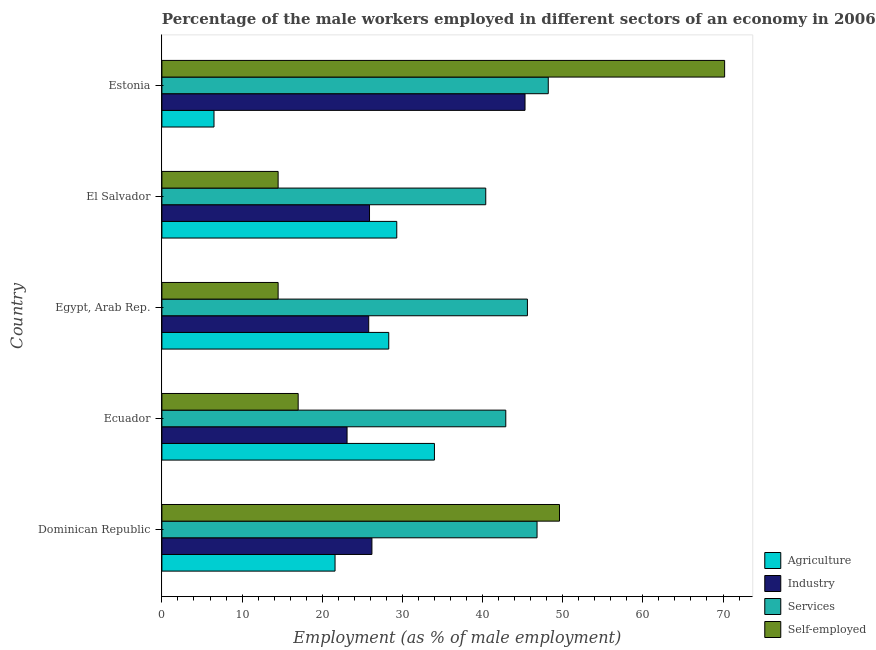What is the label of the 2nd group of bars from the top?
Offer a terse response. El Salvador. What is the percentage of male workers in services in Ecuador?
Your answer should be very brief. 42.9. Across all countries, what is the maximum percentage of self employed male workers?
Keep it short and to the point. 70.2. Across all countries, what is the minimum percentage of male workers in industry?
Give a very brief answer. 23.1. In which country was the percentage of male workers in services maximum?
Provide a succinct answer. Estonia. In which country was the percentage of male workers in services minimum?
Provide a succinct answer. El Salvador. What is the total percentage of male workers in agriculture in the graph?
Your response must be concise. 119.7. What is the difference between the percentage of self employed male workers in Ecuador and that in El Salvador?
Ensure brevity in your answer.  2.5. What is the difference between the percentage of self employed male workers in Estonia and the percentage of male workers in industry in Ecuador?
Offer a terse response. 47.1. What is the average percentage of male workers in industry per country?
Your answer should be compact. 29.26. What is the difference between the percentage of male workers in services and percentage of male workers in industry in Ecuador?
Ensure brevity in your answer.  19.8. What is the ratio of the percentage of male workers in services in Ecuador to that in Estonia?
Offer a very short reply. 0.89. Is the percentage of self employed male workers in Ecuador less than that in Egypt, Arab Rep.?
Keep it short and to the point. No. What is the difference between the highest and the second highest percentage of male workers in industry?
Give a very brief answer. 19.1. In how many countries, is the percentage of male workers in agriculture greater than the average percentage of male workers in agriculture taken over all countries?
Give a very brief answer. 3. Is it the case that in every country, the sum of the percentage of self employed male workers and percentage of male workers in agriculture is greater than the sum of percentage of male workers in services and percentage of male workers in industry?
Provide a succinct answer. No. What does the 1st bar from the top in El Salvador represents?
Provide a succinct answer. Self-employed. What does the 4th bar from the bottom in Ecuador represents?
Your answer should be compact. Self-employed. How many countries are there in the graph?
Offer a very short reply. 5. What is the difference between two consecutive major ticks on the X-axis?
Your answer should be compact. 10. Where does the legend appear in the graph?
Offer a terse response. Bottom right. What is the title of the graph?
Provide a succinct answer. Percentage of the male workers employed in different sectors of an economy in 2006. Does "Agriculture" appear as one of the legend labels in the graph?
Make the answer very short. Yes. What is the label or title of the X-axis?
Your response must be concise. Employment (as % of male employment). What is the Employment (as % of male employment) in Agriculture in Dominican Republic?
Make the answer very short. 21.6. What is the Employment (as % of male employment) in Industry in Dominican Republic?
Your answer should be compact. 26.2. What is the Employment (as % of male employment) of Services in Dominican Republic?
Give a very brief answer. 46.8. What is the Employment (as % of male employment) in Self-employed in Dominican Republic?
Offer a very short reply. 49.6. What is the Employment (as % of male employment) of Industry in Ecuador?
Your answer should be very brief. 23.1. What is the Employment (as % of male employment) of Services in Ecuador?
Provide a short and direct response. 42.9. What is the Employment (as % of male employment) in Self-employed in Ecuador?
Give a very brief answer. 17. What is the Employment (as % of male employment) of Agriculture in Egypt, Arab Rep.?
Make the answer very short. 28.3. What is the Employment (as % of male employment) of Industry in Egypt, Arab Rep.?
Your response must be concise. 25.8. What is the Employment (as % of male employment) of Services in Egypt, Arab Rep.?
Your answer should be compact. 45.6. What is the Employment (as % of male employment) in Agriculture in El Salvador?
Your answer should be compact. 29.3. What is the Employment (as % of male employment) in Industry in El Salvador?
Offer a terse response. 25.9. What is the Employment (as % of male employment) in Services in El Salvador?
Your response must be concise. 40.4. What is the Employment (as % of male employment) in Self-employed in El Salvador?
Your answer should be compact. 14.5. What is the Employment (as % of male employment) of Agriculture in Estonia?
Your answer should be very brief. 6.5. What is the Employment (as % of male employment) of Industry in Estonia?
Offer a terse response. 45.3. What is the Employment (as % of male employment) in Services in Estonia?
Your answer should be compact. 48.2. What is the Employment (as % of male employment) in Self-employed in Estonia?
Provide a succinct answer. 70.2. Across all countries, what is the maximum Employment (as % of male employment) of Industry?
Make the answer very short. 45.3. Across all countries, what is the maximum Employment (as % of male employment) of Services?
Offer a very short reply. 48.2. Across all countries, what is the maximum Employment (as % of male employment) of Self-employed?
Offer a very short reply. 70.2. Across all countries, what is the minimum Employment (as % of male employment) in Agriculture?
Your answer should be compact. 6.5. Across all countries, what is the minimum Employment (as % of male employment) in Industry?
Offer a terse response. 23.1. Across all countries, what is the minimum Employment (as % of male employment) of Services?
Keep it short and to the point. 40.4. Across all countries, what is the minimum Employment (as % of male employment) of Self-employed?
Give a very brief answer. 14.5. What is the total Employment (as % of male employment) of Agriculture in the graph?
Ensure brevity in your answer.  119.7. What is the total Employment (as % of male employment) in Industry in the graph?
Provide a succinct answer. 146.3. What is the total Employment (as % of male employment) in Services in the graph?
Offer a very short reply. 223.9. What is the total Employment (as % of male employment) of Self-employed in the graph?
Offer a terse response. 165.8. What is the difference between the Employment (as % of male employment) of Agriculture in Dominican Republic and that in Ecuador?
Offer a very short reply. -12.4. What is the difference between the Employment (as % of male employment) of Industry in Dominican Republic and that in Ecuador?
Your response must be concise. 3.1. What is the difference between the Employment (as % of male employment) of Services in Dominican Republic and that in Ecuador?
Make the answer very short. 3.9. What is the difference between the Employment (as % of male employment) in Self-employed in Dominican Republic and that in Ecuador?
Your answer should be compact. 32.6. What is the difference between the Employment (as % of male employment) of Agriculture in Dominican Republic and that in Egypt, Arab Rep.?
Make the answer very short. -6.7. What is the difference between the Employment (as % of male employment) of Services in Dominican Republic and that in Egypt, Arab Rep.?
Offer a very short reply. 1.2. What is the difference between the Employment (as % of male employment) of Self-employed in Dominican Republic and that in Egypt, Arab Rep.?
Keep it short and to the point. 35.1. What is the difference between the Employment (as % of male employment) of Agriculture in Dominican Republic and that in El Salvador?
Your response must be concise. -7.7. What is the difference between the Employment (as % of male employment) in Industry in Dominican Republic and that in El Salvador?
Provide a short and direct response. 0.3. What is the difference between the Employment (as % of male employment) of Self-employed in Dominican Republic and that in El Salvador?
Your answer should be very brief. 35.1. What is the difference between the Employment (as % of male employment) of Industry in Dominican Republic and that in Estonia?
Give a very brief answer. -19.1. What is the difference between the Employment (as % of male employment) in Services in Dominican Republic and that in Estonia?
Your answer should be compact. -1.4. What is the difference between the Employment (as % of male employment) of Self-employed in Dominican Republic and that in Estonia?
Provide a short and direct response. -20.6. What is the difference between the Employment (as % of male employment) of Agriculture in Ecuador and that in Egypt, Arab Rep.?
Offer a terse response. 5.7. What is the difference between the Employment (as % of male employment) in Industry in Ecuador and that in Egypt, Arab Rep.?
Offer a terse response. -2.7. What is the difference between the Employment (as % of male employment) in Agriculture in Ecuador and that in El Salvador?
Keep it short and to the point. 4.7. What is the difference between the Employment (as % of male employment) of Industry in Ecuador and that in El Salvador?
Ensure brevity in your answer.  -2.8. What is the difference between the Employment (as % of male employment) in Agriculture in Ecuador and that in Estonia?
Give a very brief answer. 27.5. What is the difference between the Employment (as % of male employment) in Industry in Ecuador and that in Estonia?
Offer a terse response. -22.2. What is the difference between the Employment (as % of male employment) of Services in Ecuador and that in Estonia?
Ensure brevity in your answer.  -5.3. What is the difference between the Employment (as % of male employment) of Self-employed in Ecuador and that in Estonia?
Your answer should be very brief. -53.2. What is the difference between the Employment (as % of male employment) of Services in Egypt, Arab Rep. and that in El Salvador?
Offer a very short reply. 5.2. What is the difference between the Employment (as % of male employment) of Agriculture in Egypt, Arab Rep. and that in Estonia?
Provide a short and direct response. 21.8. What is the difference between the Employment (as % of male employment) in Industry in Egypt, Arab Rep. and that in Estonia?
Give a very brief answer. -19.5. What is the difference between the Employment (as % of male employment) in Self-employed in Egypt, Arab Rep. and that in Estonia?
Provide a short and direct response. -55.7. What is the difference between the Employment (as % of male employment) of Agriculture in El Salvador and that in Estonia?
Your response must be concise. 22.8. What is the difference between the Employment (as % of male employment) of Industry in El Salvador and that in Estonia?
Ensure brevity in your answer.  -19.4. What is the difference between the Employment (as % of male employment) of Self-employed in El Salvador and that in Estonia?
Give a very brief answer. -55.7. What is the difference between the Employment (as % of male employment) in Agriculture in Dominican Republic and the Employment (as % of male employment) in Industry in Ecuador?
Provide a succinct answer. -1.5. What is the difference between the Employment (as % of male employment) in Agriculture in Dominican Republic and the Employment (as % of male employment) in Services in Ecuador?
Give a very brief answer. -21.3. What is the difference between the Employment (as % of male employment) in Agriculture in Dominican Republic and the Employment (as % of male employment) in Self-employed in Ecuador?
Give a very brief answer. 4.6. What is the difference between the Employment (as % of male employment) of Industry in Dominican Republic and the Employment (as % of male employment) of Services in Ecuador?
Offer a very short reply. -16.7. What is the difference between the Employment (as % of male employment) in Services in Dominican Republic and the Employment (as % of male employment) in Self-employed in Ecuador?
Your answer should be very brief. 29.8. What is the difference between the Employment (as % of male employment) of Agriculture in Dominican Republic and the Employment (as % of male employment) of Services in Egypt, Arab Rep.?
Offer a very short reply. -24. What is the difference between the Employment (as % of male employment) in Industry in Dominican Republic and the Employment (as % of male employment) in Services in Egypt, Arab Rep.?
Keep it short and to the point. -19.4. What is the difference between the Employment (as % of male employment) in Industry in Dominican Republic and the Employment (as % of male employment) in Self-employed in Egypt, Arab Rep.?
Provide a short and direct response. 11.7. What is the difference between the Employment (as % of male employment) of Services in Dominican Republic and the Employment (as % of male employment) of Self-employed in Egypt, Arab Rep.?
Make the answer very short. 32.3. What is the difference between the Employment (as % of male employment) in Agriculture in Dominican Republic and the Employment (as % of male employment) in Industry in El Salvador?
Provide a succinct answer. -4.3. What is the difference between the Employment (as % of male employment) of Agriculture in Dominican Republic and the Employment (as % of male employment) of Services in El Salvador?
Keep it short and to the point. -18.8. What is the difference between the Employment (as % of male employment) in Services in Dominican Republic and the Employment (as % of male employment) in Self-employed in El Salvador?
Your response must be concise. 32.3. What is the difference between the Employment (as % of male employment) of Agriculture in Dominican Republic and the Employment (as % of male employment) of Industry in Estonia?
Make the answer very short. -23.7. What is the difference between the Employment (as % of male employment) in Agriculture in Dominican Republic and the Employment (as % of male employment) in Services in Estonia?
Your answer should be compact. -26.6. What is the difference between the Employment (as % of male employment) of Agriculture in Dominican Republic and the Employment (as % of male employment) of Self-employed in Estonia?
Your answer should be compact. -48.6. What is the difference between the Employment (as % of male employment) in Industry in Dominican Republic and the Employment (as % of male employment) in Self-employed in Estonia?
Make the answer very short. -44. What is the difference between the Employment (as % of male employment) in Services in Dominican Republic and the Employment (as % of male employment) in Self-employed in Estonia?
Give a very brief answer. -23.4. What is the difference between the Employment (as % of male employment) of Industry in Ecuador and the Employment (as % of male employment) of Services in Egypt, Arab Rep.?
Keep it short and to the point. -22.5. What is the difference between the Employment (as % of male employment) in Industry in Ecuador and the Employment (as % of male employment) in Self-employed in Egypt, Arab Rep.?
Keep it short and to the point. 8.6. What is the difference between the Employment (as % of male employment) in Services in Ecuador and the Employment (as % of male employment) in Self-employed in Egypt, Arab Rep.?
Ensure brevity in your answer.  28.4. What is the difference between the Employment (as % of male employment) in Agriculture in Ecuador and the Employment (as % of male employment) in Industry in El Salvador?
Keep it short and to the point. 8.1. What is the difference between the Employment (as % of male employment) of Agriculture in Ecuador and the Employment (as % of male employment) of Services in El Salvador?
Ensure brevity in your answer.  -6.4. What is the difference between the Employment (as % of male employment) of Agriculture in Ecuador and the Employment (as % of male employment) of Self-employed in El Salvador?
Your answer should be very brief. 19.5. What is the difference between the Employment (as % of male employment) in Industry in Ecuador and the Employment (as % of male employment) in Services in El Salvador?
Provide a short and direct response. -17.3. What is the difference between the Employment (as % of male employment) in Services in Ecuador and the Employment (as % of male employment) in Self-employed in El Salvador?
Offer a very short reply. 28.4. What is the difference between the Employment (as % of male employment) in Agriculture in Ecuador and the Employment (as % of male employment) in Self-employed in Estonia?
Give a very brief answer. -36.2. What is the difference between the Employment (as % of male employment) of Industry in Ecuador and the Employment (as % of male employment) of Services in Estonia?
Offer a very short reply. -25.1. What is the difference between the Employment (as % of male employment) in Industry in Ecuador and the Employment (as % of male employment) in Self-employed in Estonia?
Provide a short and direct response. -47.1. What is the difference between the Employment (as % of male employment) of Services in Ecuador and the Employment (as % of male employment) of Self-employed in Estonia?
Offer a terse response. -27.3. What is the difference between the Employment (as % of male employment) of Agriculture in Egypt, Arab Rep. and the Employment (as % of male employment) of Industry in El Salvador?
Ensure brevity in your answer.  2.4. What is the difference between the Employment (as % of male employment) in Agriculture in Egypt, Arab Rep. and the Employment (as % of male employment) in Self-employed in El Salvador?
Your response must be concise. 13.8. What is the difference between the Employment (as % of male employment) in Industry in Egypt, Arab Rep. and the Employment (as % of male employment) in Services in El Salvador?
Provide a short and direct response. -14.6. What is the difference between the Employment (as % of male employment) of Services in Egypt, Arab Rep. and the Employment (as % of male employment) of Self-employed in El Salvador?
Make the answer very short. 31.1. What is the difference between the Employment (as % of male employment) in Agriculture in Egypt, Arab Rep. and the Employment (as % of male employment) in Services in Estonia?
Your response must be concise. -19.9. What is the difference between the Employment (as % of male employment) of Agriculture in Egypt, Arab Rep. and the Employment (as % of male employment) of Self-employed in Estonia?
Offer a very short reply. -41.9. What is the difference between the Employment (as % of male employment) of Industry in Egypt, Arab Rep. and the Employment (as % of male employment) of Services in Estonia?
Provide a succinct answer. -22.4. What is the difference between the Employment (as % of male employment) in Industry in Egypt, Arab Rep. and the Employment (as % of male employment) in Self-employed in Estonia?
Your response must be concise. -44.4. What is the difference between the Employment (as % of male employment) in Services in Egypt, Arab Rep. and the Employment (as % of male employment) in Self-employed in Estonia?
Offer a terse response. -24.6. What is the difference between the Employment (as % of male employment) in Agriculture in El Salvador and the Employment (as % of male employment) in Industry in Estonia?
Make the answer very short. -16. What is the difference between the Employment (as % of male employment) in Agriculture in El Salvador and the Employment (as % of male employment) in Services in Estonia?
Provide a short and direct response. -18.9. What is the difference between the Employment (as % of male employment) of Agriculture in El Salvador and the Employment (as % of male employment) of Self-employed in Estonia?
Offer a terse response. -40.9. What is the difference between the Employment (as % of male employment) of Industry in El Salvador and the Employment (as % of male employment) of Services in Estonia?
Make the answer very short. -22.3. What is the difference between the Employment (as % of male employment) of Industry in El Salvador and the Employment (as % of male employment) of Self-employed in Estonia?
Provide a short and direct response. -44.3. What is the difference between the Employment (as % of male employment) of Services in El Salvador and the Employment (as % of male employment) of Self-employed in Estonia?
Offer a terse response. -29.8. What is the average Employment (as % of male employment) in Agriculture per country?
Make the answer very short. 23.94. What is the average Employment (as % of male employment) of Industry per country?
Offer a very short reply. 29.26. What is the average Employment (as % of male employment) in Services per country?
Ensure brevity in your answer.  44.78. What is the average Employment (as % of male employment) in Self-employed per country?
Offer a terse response. 33.16. What is the difference between the Employment (as % of male employment) of Agriculture and Employment (as % of male employment) of Services in Dominican Republic?
Your response must be concise. -25.2. What is the difference between the Employment (as % of male employment) in Industry and Employment (as % of male employment) in Services in Dominican Republic?
Provide a short and direct response. -20.6. What is the difference between the Employment (as % of male employment) in Industry and Employment (as % of male employment) in Self-employed in Dominican Republic?
Offer a very short reply. -23.4. What is the difference between the Employment (as % of male employment) of Agriculture and Employment (as % of male employment) of Services in Ecuador?
Provide a short and direct response. -8.9. What is the difference between the Employment (as % of male employment) of Agriculture and Employment (as % of male employment) of Self-employed in Ecuador?
Your response must be concise. 17. What is the difference between the Employment (as % of male employment) of Industry and Employment (as % of male employment) of Services in Ecuador?
Make the answer very short. -19.8. What is the difference between the Employment (as % of male employment) in Services and Employment (as % of male employment) in Self-employed in Ecuador?
Provide a succinct answer. 25.9. What is the difference between the Employment (as % of male employment) in Agriculture and Employment (as % of male employment) in Industry in Egypt, Arab Rep.?
Offer a terse response. 2.5. What is the difference between the Employment (as % of male employment) of Agriculture and Employment (as % of male employment) of Services in Egypt, Arab Rep.?
Your answer should be compact. -17.3. What is the difference between the Employment (as % of male employment) in Industry and Employment (as % of male employment) in Services in Egypt, Arab Rep.?
Your answer should be compact. -19.8. What is the difference between the Employment (as % of male employment) of Industry and Employment (as % of male employment) of Self-employed in Egypt, Arab Rep.?
Provide a short and direct response. 11.3. What is the difference between the Employment (as % of male employment) in Services and Employment (as % of male employment) in Self-employed in Egypt, Arab Rep.?
Provide a succinct answer. 31.1. What is the difference between the Employment (as % of male employment) in Agriculture and Employment (as % of male employment) in Self-employed in El Salvador?
Keep it short and to the point. 14.8. What is the difference between the Employment (as % of male employment) of Industry and Employment (as % of male employment) of Services in El Salvador?
Offer a terse response. -14.5. What is the difference between the Employment (as % of male employment) in Industry and Employment (as % of male employment) in Self-employed in El Salvador?
Keep it short and to the point. 11.4. What is the difference between the Employment (as % of male employment) in Services and Employment (as % of male employment) in Self-employed in El Salvador?
Your answer should be compact. 25.9. What is the difference between the Employment (as % of male employment) in Agriculture and Employment (as % of male employment) in Industry in Estonia?
Provide a succinct answer. -38.8. What is the difference between the Employment (as % of male employment) in Agriculture and Employment (as % of male employment) in Services in Estonia?
Keep it short and to the point. -41.7. What is the difference between the Employment (as % of male employment) in Agriculture and Employment (as % of male employment) in Self-employed in Estonia?
Keep it short and to the point. -63.7. What is the difference between the Employment (as % of male employment) of Industry and Employment (as % of male employment) of Services in Estonia?
Give a very brief answer. -2.9. What is the difference between the Employment (as % of male employment) in Industry and Employment (as % of male employment) in Self-employed in Estonia?
Provide a short and direct response. -24.9. What is the difference between the Employment (as % of male employment) in Services and Employment (as % of male employment) in Self-employed in Estonia?
Offer a terse response. -22. What is the ratio of the Employment (as % of male employment) in Agriculture in Dominican Republic to that in Ecuador?
Ensure brevity in your answer.  0.64. What is the ratio of the Employment (as % of male employment) of Industry in Dominican Republic to that in Ecuador?
Make the answer very short. 1.13. What is the ratio of the Employment (as % of male employment) of Services in Dominican Republic to that in Ecuador?
Your answer should be very brief. 1.09. What is the ratio of the Employment (as % of male employment) of Self-employed in Dominican Republic to that in Ecuador?
Keep it short and to the point. 2.92. What is the ratio of the Employment (as % of male employment) in Agriculture in Dominican Republic to that in Egypt, Arab Rep.?
Ensure brevity in your answer.  0.76. What is the ratio of the Employment (as % of male employment) of Industry in Dominican Republic to that in Egypt, Arab Rep.?
Keep it short and to the point. 1.02. What is the ratio of the Employment (as % of male employment) of Services in Dominican Republic to that in Egypt, Arab Rep.?
Offer a very short reply. 1.03. What is the ratio of the Employment (as % of male employment) in Self-employed in Dominican Republic to that in Egypt, Arab Rep.?
Offer a very short reply. 3.42. What is the ratio of the Employment (as % of male employment) in Agriculture in Dominican Republic to that in El Salvador?
Provide a short and direct response. 0.74. What is the ratio of the Employment (as % of male employment) of Industry in Dominican Republic to that in El Salvador?
Provide a short and direct response. 1.01. What is the ratio of the Employment (as % of male employment) in Services in Dominican Republic to that in El Salvador?
Your response must be concise. 1.16. What is the ratio of the Employment (as % of male employment) in Self-employed in Dominican Republic to that in El Salvador?
Offer a terse response. 3.42. What is the ratio of the Employment (as % of male employment) of Agriculture in Dominican Republic to that in Estonia?
Offer a very short reply. 3.32. What is the ratio of the Employment (as % of male employment) of Industry in Dominican Republic to that in Estonia?
Offer a terse response. 0.58. What is the ratio of the Employment (as % of male employment) of Services in Dominican Republic to that in Estonia?
Give a very brief answer. 0.97. What is the ratio of the Employment (as % of male employment) of Self-employed in Dominican Republic to that in Estonia?
Offer a very short reply. 0.71. What is the ratio of the Employment (as % of male employment) in Agriculture in Ecuador to that in Egypt, Arab Rep.?
Give a very brief answer. 1.2. What is the ratio of the Employment (as % of male employment) of Industry in Ecuador to that in Egypt, Arab Rep.?
Offer a terse response. 0.9. What is the ratio of the Employment (as % of male employment) of Services in Ecuador to that in Egypt, Arab Rep.?
Make the answer very short. 0.94. What is the ratio of the Employment (as % of male employment) of Self-employed in Ecuador to that in Egypt, Arab Rep.?
Your answer should be compact. 1.17. What is the ratio of the Employment (as % of male employment) in Agriculture in Ecuador to that in El Salvador?
Your answer should be compact. 1.16. What is the ratio of the Employment (as % of male employment) in Industry in Ecuador to that in El Salvador?
Your response must be concise. 0.89. What is the ratio of the Employment (as % of male employment) of Services in Ecuador to that in El Salvador?
Offer a very short reply. 1.06. What is the ratio of the Employment (as % of male employment) of Self-employed in Ecuador to that in El Salvador?
Keep it short and to the point. 1.17. What is the ratio of the Employment (as % of male employment) in Agriculture in Ecuador to that in Estonia?
Make the answer very short. 5.23. What is the ratio of the Employment (as % of male employment) in Industry in Ecuador to that in Estonia?
Your response must be concise. 0.51. What is the ratio of the Employment (as % of male employment) of Services in Ecuador to that in Estonia?
Offer a very short reply. 0.89. What is the ratio of the Employment (as % of male employment) of Self-employed in Ecuador to that in Estonia?
Your answer should be compact. 0.24. What is the ratio of the Employment (as % of male employment) in Agriculture in Egypt, Arab Rep. to that in El Salvador?
Keep it short and to the point. 0.97. What is the ratio of the Employment (as % of male employment) in Industry in Egypt, Arab Rep. to that in El Salvador?
Make the answer very short. 1. What is the ratio of the Employment (as % of male employment) in Services in Egypt, Arab Rep. to that in El Salvador?
Make the answer very short. 1.13. What is the ratio of the Employment (as % of male employment) in Self-employed in Egypt, Arab Rep. to that in El Salvador?
Keep it short and to the point. 1. What is the ratio of the Employment (as % of male employment) in Agriculture in Egypt, Arab Rep. to that in Estonia?
Offer a terse response. 4.35. What is the ratio of the Employment (as % of male employment) of Industry in Egypt, Arab Rep. to that in Estonia?
Your answer should be compact. 0.57. What is the ratio of the Employment (as % of male employment) in Services in Egypt, Arab Rep. to that in Estonia?
Give a very brief answer. 0.95. What is the ratio of the Employment (as % of male employment) of Self-employed in Egypt, Arab Rep. to that in Estonia?
Provide a short and direct response. 0.21. What is the ratio of the Employment (as % of male employment) of Agriculture in El Salvador to that in Estonia?
Make the answer very short. 4.51. What is the ratio of the Employment (as % of male employment) of Industry in El Salvador to that in Estonia?
Provide a short and direct response. 0.57. What is the ratio of the Employment (as % of male employment) of Services in El Salvador to that in Estonia?
Your answer should be very brief. 0.84. What is the ratio of the Employment (as % of male employment) of Self-employed in El Salvador to that in Estonia?
Your answer should be very brief. 0.21. What is the difference between the highest and the second highest Employment (as % of male employment) in Agriculture?
Your response must be concise. 4.7. What is the difference between the highest and the second highest Employment (as % of male employment) in Industry?
Keep it short and to the point. 19.1. What is the difference between the highest and the second highest Employment (as % of male employment) in Self-employed?
Your answer should be very brief. 20.6. What is the difference between the highest and the lowest Employment (as % of male employment) of Agriculture?
Offer a very short reply. 27.5. What is the difference between the highest and the lowest Employment (as % of male employment) of Industry?
Ensure brevity in your answer.  22.2. What is the difference between the highest and the lowest Employment (as % of male employment) in Services?
Your answer should be very brief. 7.8. What is the difference between the highest and the lowest Employment (as % of male employment) of Self-employed?
Your answer should be very brief. 55.7. 